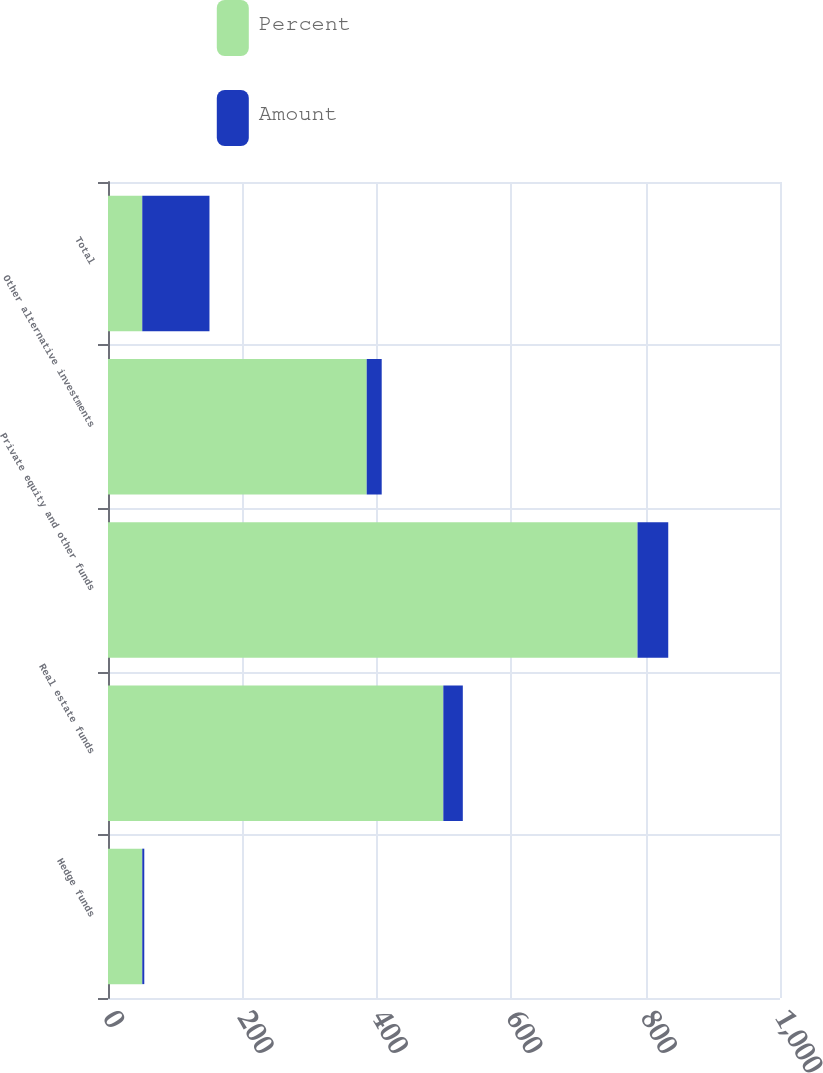<chart> <loc_0><loc_0><loc_500><loc_500><stacked_bar_chart><ecel><fcel>Hedge funds<fcel>Real estate funds<fcel>Private equity and other funds<fcel>Other alternative investments<fcel>Total<nl><fcel>Percent<fcel>51<fcel>499<fcel>788<fcel>385<fcel>51<nl><fcel>Amount<fcel>3<fcel>29<fcel>45.7<fcel>22.3<fcel>100<nl></chart> 